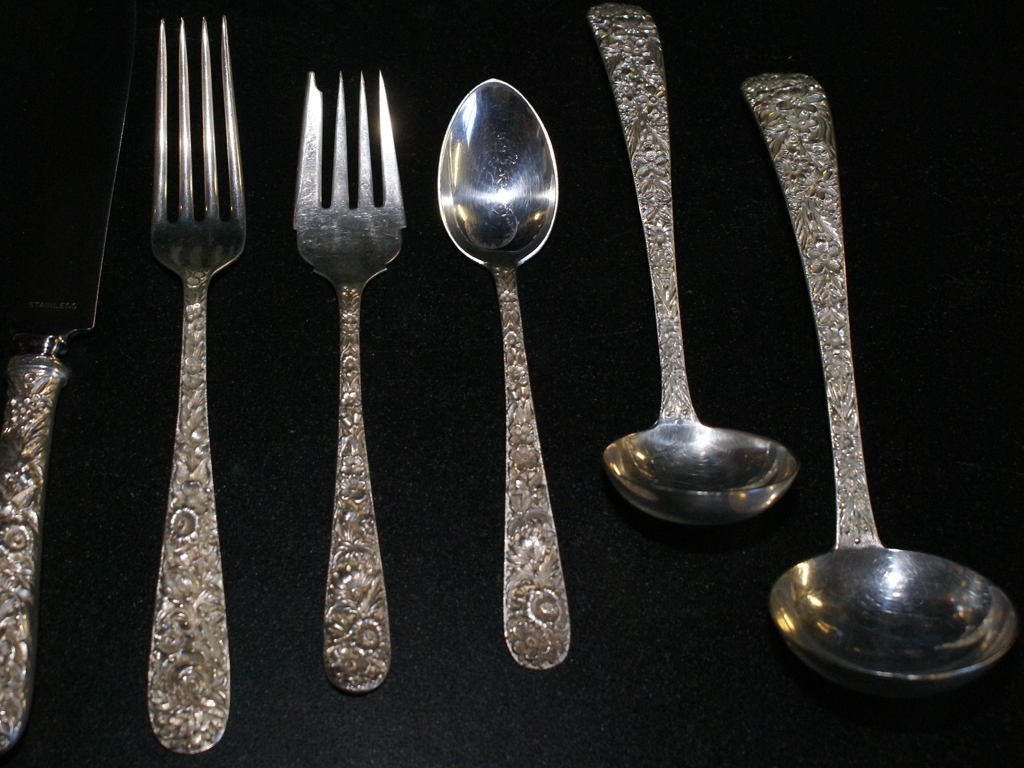What is the condition of the spoon and knife and fork? The spoons, knife, and forks in the image appear to be in good condition with a high level of polish, reflecting the light with a noticeable shine. The decorative handles feature an ornate floral pattern, suggesting they may be part of a fine dining set or special occasion cutlery. 